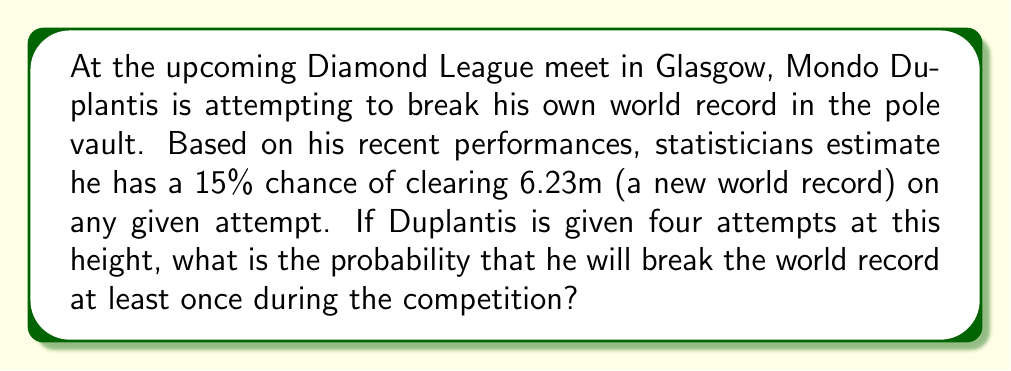Solve this math problem. Let's approach this step-by-step:

1) First, we need to understand what the question is asking. We want to find the probability of Duplantis breaking the world record at least once in four attempts.

2) It's often easier to calculate the probability of an event not happening and then subtract that from 1 to get the probability of it happening at least once.

3) The probability of Duplantis not breaking the record on a single attempt is:

   $1 - 0.15 = 0.85$ or 85%

4) For him to not break the record over all four attempts, he must fail on each attempt. The probability of this is:

   $0.85^4 = 0.5220$ or 52.20%

5) Therefore, the probability of him breaking the record at least once is:

   $1 - 0.5220 = 0.4780$ or 47.80%

6) We can also calculate this directly using the formula for the probability of at least one success in n independent trials:

   $P(\text{at least one success}) = 1 - (1-p)^n$

   Where $p$ is the probability of success on a single trial and $n$ is the number of trials.

   $1 - (1-0.15)^4 = 1 - 0.85^4 = 1 - 0.5220 = 0.4780$

This confirms our earlier calculation.
Answer: 0.4780 or 47.80% 